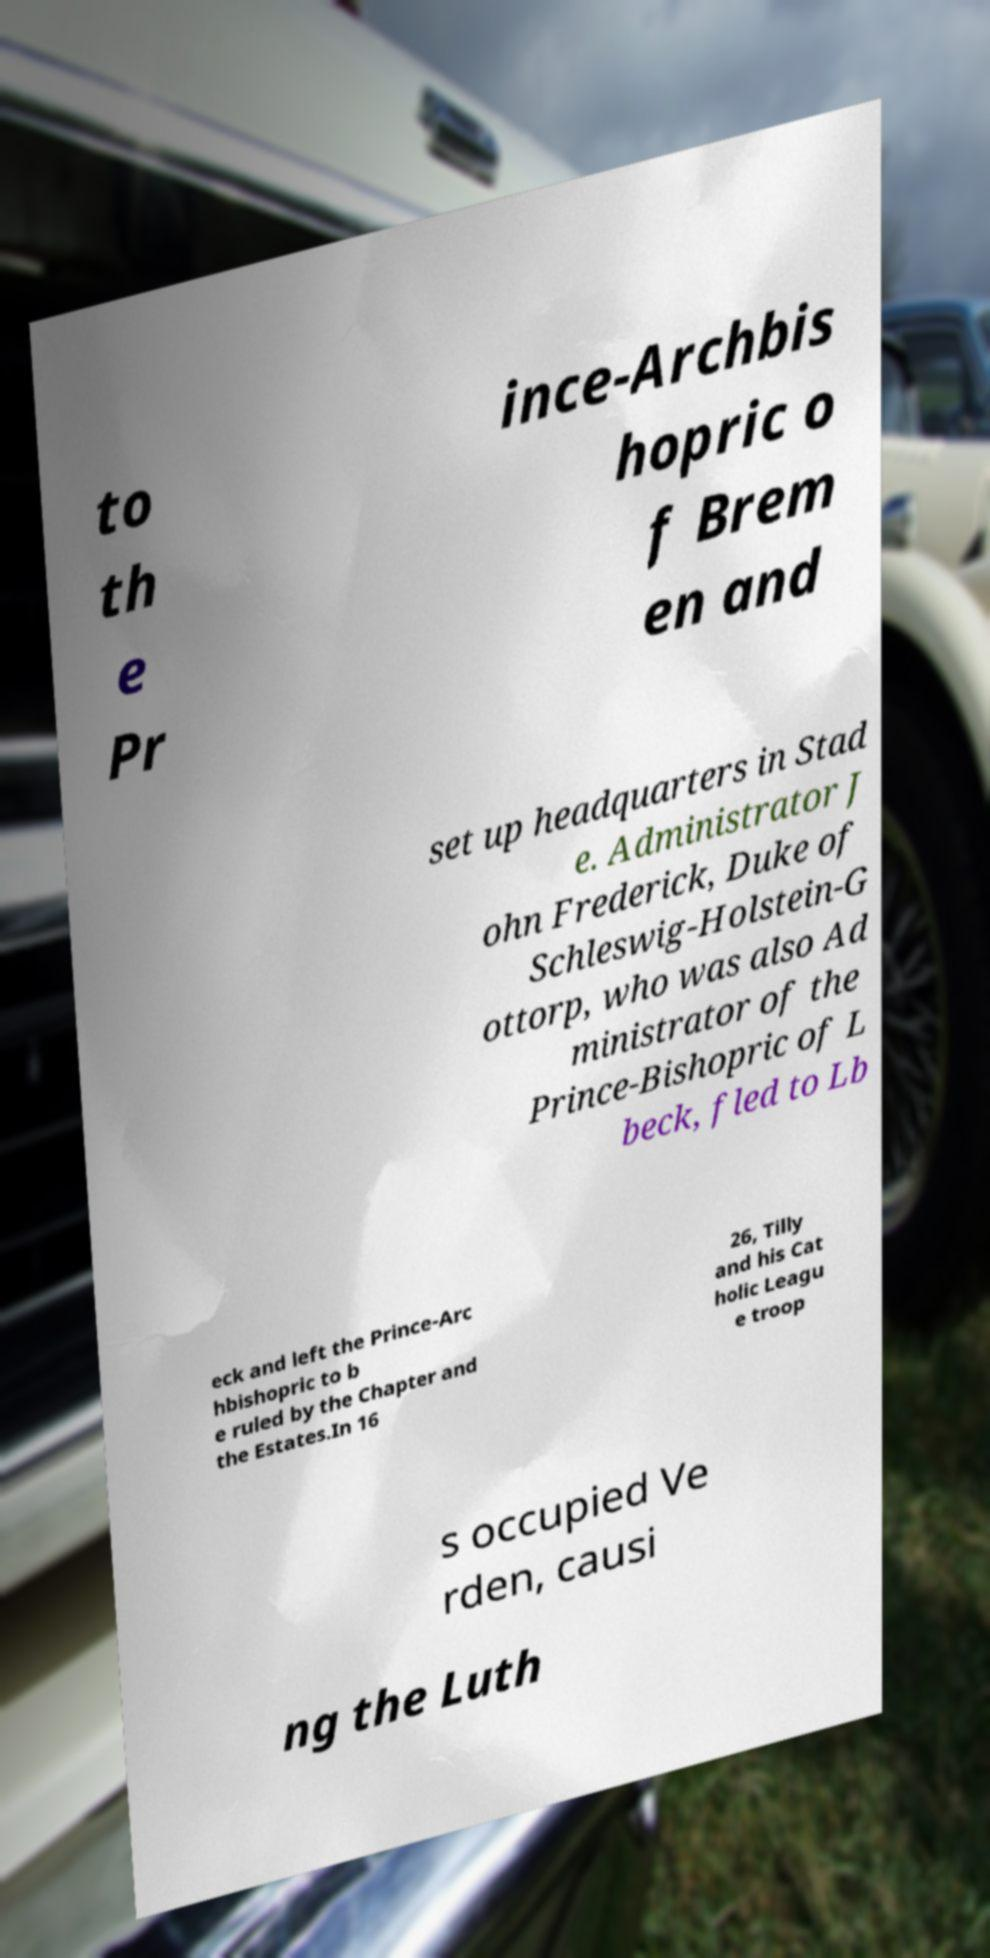I need the written content from this picture converted into text. Can you do that? to th e Pr ince-Archbis hopric o f Brem en and set up headquarters in Stad e. Administrator J ohn Frederick, Duke of Schleswig-Holstein-G ottorp, who was also Ad ministrator of the Prince-Bishopric of L beck, fled to Lb eck and left the Prince-Arc hbishopric to b e ruled by the Chapter and the Estates.In 16 26, Tilly and his Cat holic Leagu e troop s occupied Ve rden, causi ng the Luth 